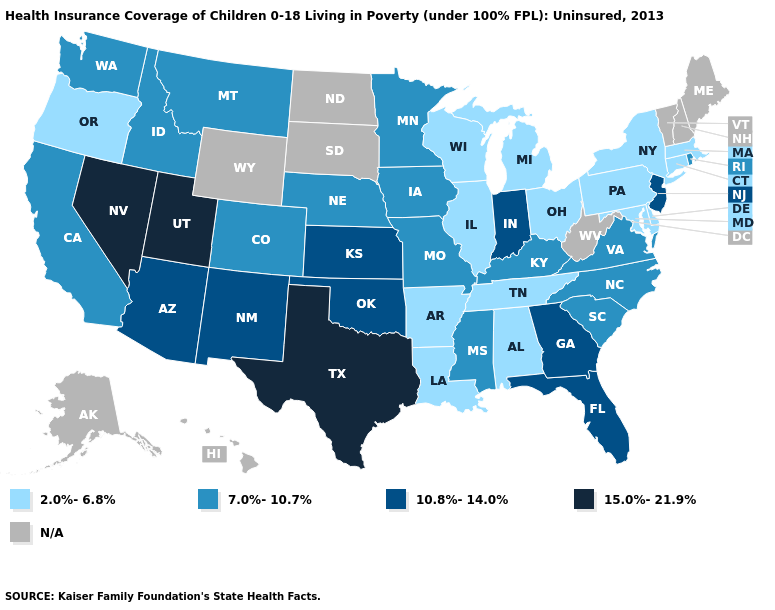Among the states that border Wyoming , which have the lowest value?
Give a very brief answer. Colorado, Idaho, Montana, Nebraska. Does the map have missing data?
Short answer required. Yes. What is the lowest value in the MidWest?
Concise answer only. 2.0%-6.8%. What is the highest value in the Northeast ?
Be succinct. 10.8%-14.0%. Name the states that have a value in the range 10.8%-14.0%?
Be succinct. Arizona, Florida, Georgia, Indiana, Kansas, New Jersey, New Mexico, Oklahoma. What is the value of Alabama?
Answer briefly. 2.0%-6.8%. How many symbols are there in the legend?
Short answer required. 5. How many symbols are there in the legend?
Concise answer only. 5. Name the states that have a value in the range 2.0%-6.8%?
Keep it brief. Alabama, Arkansas, Connecticut, Delaware, Illinois, Louisiana, Maryland, Massachusetts, Michigan, New York, Ohio, Oregon, Pennsylvania, Tennessee, Wisconsin. What is the value of Arkansas?
Be succinct. 2.0%-6.8%. What is the value of Colorado?
Short answer required. 7.0%-10.7%. What is the value of Florida?
Write a very short answer. 10.8%-14.0%. 